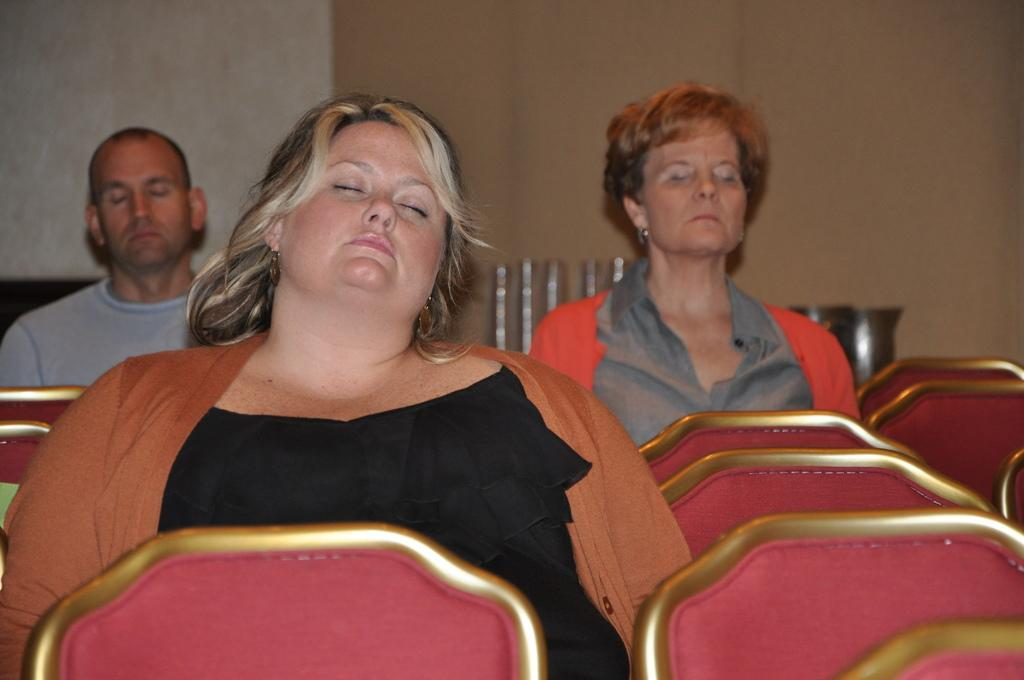What is happening in the image involving a group of people? There is a group of people in the image, and they are sitting on chairs. Can you describe the setting of the image? The people are sitting on chairs, and there are objects visible in the background. What is present in the background of the image? There is a wall in the background of the image. What type of wrist can be seen on the people in the image? There is no mention of wrists or any specific wrist type in the image. Can you describe the road visible in the image? There is no road visible in the image; it only shows a group of people sitting on chairs with a wall in the background. 